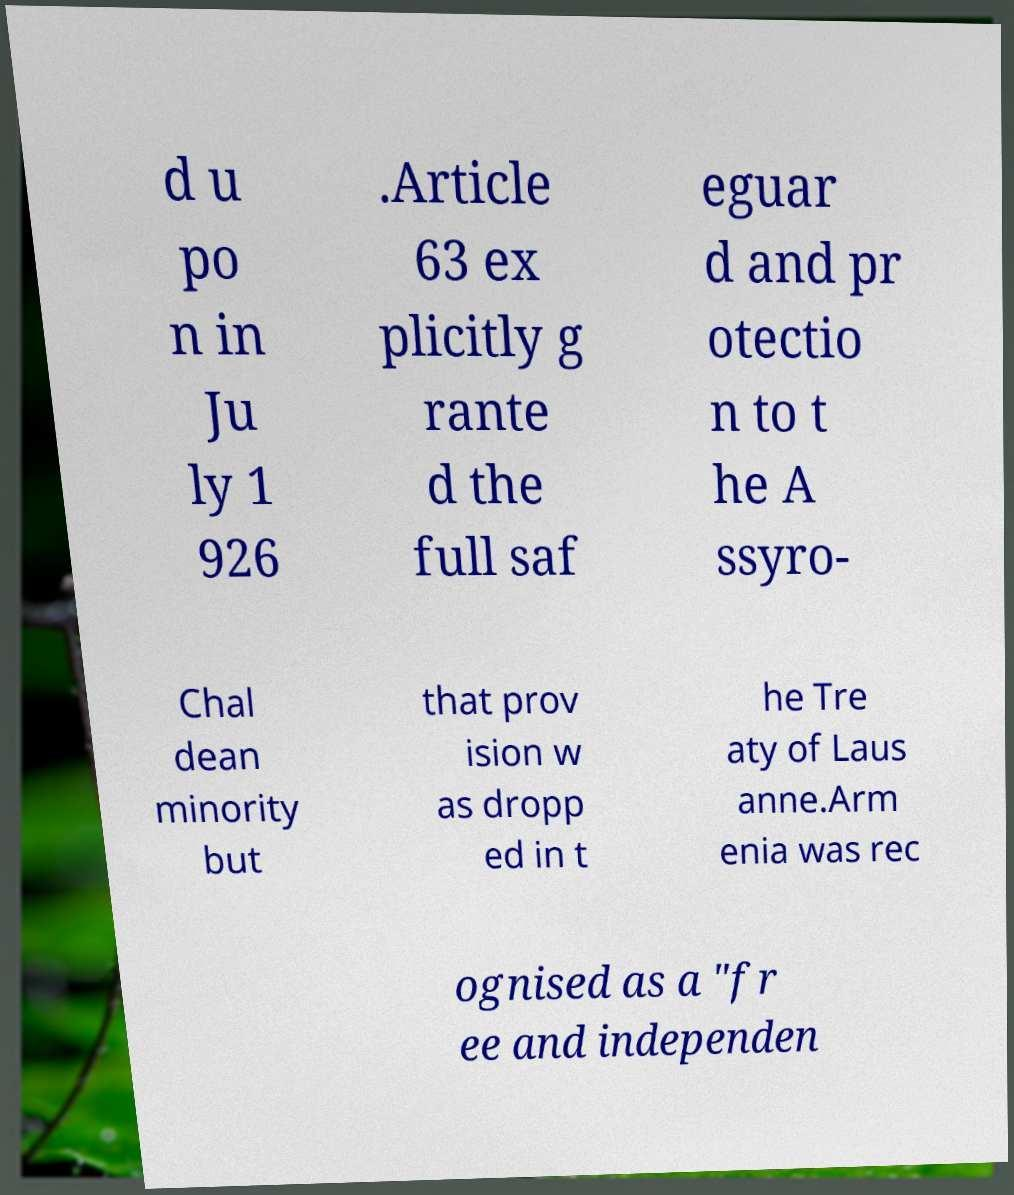For documentation purposes, I need the text within this image transcribed. Could you provide that? d u po n in Ju ly 1 926 .Article 63 ex plicitly g rante d the full saf eguar d and pr otectio n to t he A ssyro- Chal dean minority but that prov ision w as dropp ed in t he Tre aty of Laus anne.Arm enia was rec ognised as a "fr ee and independen 